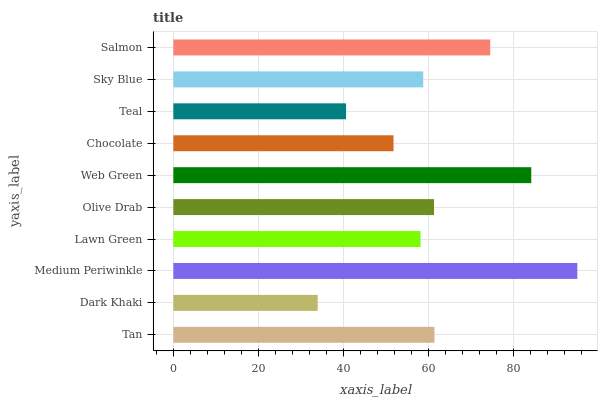Is Dark Khaki the minimum?
Answer yes or no. Yes. Is Medium Periwinkle the maximum?
Answer yes or no. Yes. Is Medium Periwinkle the minimum?
Answer yes or no. No. Is Dark Khaki the maximum?
Answer yes or no. No. Is Medium Periwinkle greater than Dark Khaki?
Answer yes or no. Yes. Is Dark Khaki less than Medium Periwinkle?
Answer yes or no. Yes. Is Dark Khaki greater than Medium Periwinkle?
Answer yes or no. No. Is Medium Periwinkle less than Dark Khaki?
Answer yes or no. No. Is Olive Drab the high median?
Answer yes or no. Yes. Is Sky Blue the low median?
Answer yes or no. Yes. Is Tan the high median?
Answer yes or no. No. Is Web Green the low median?
Answer yes or no. No. 